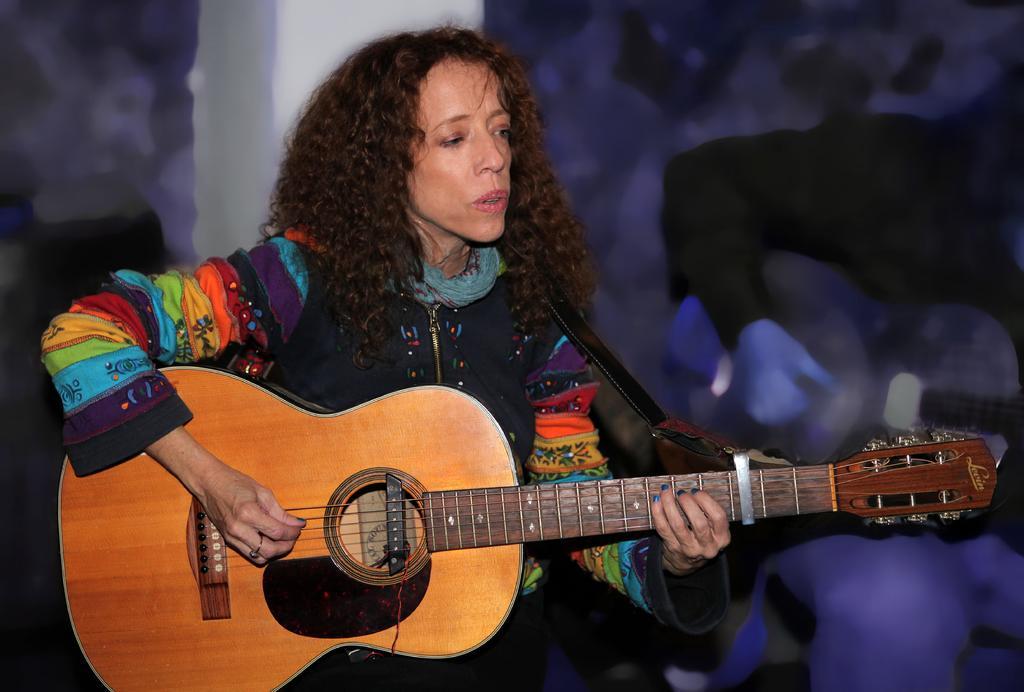Can you describe this image briefly? In this picture we can see a woman with curly hair, sitting and playing a guitar. 